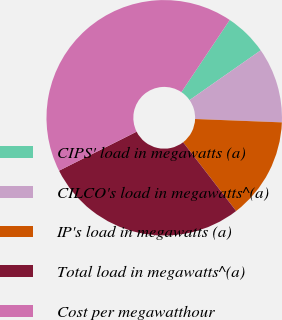<chart> <loc_0><loc_0><loc_500><loc_500><pie_chart><fcel>CIPS' load in megawatts (a)<fcel>CILCO's load in megawatts^(a)<fcel>IP's load in megawatts (a)<fcel>Total load in megawatts^(a)<fcel>Cost per megawatthour<nl><fcel>5.9%<fcel>10.33%<fcel>13.92%<fcel>28.04%<fcel>41.8%<nl></chart> 